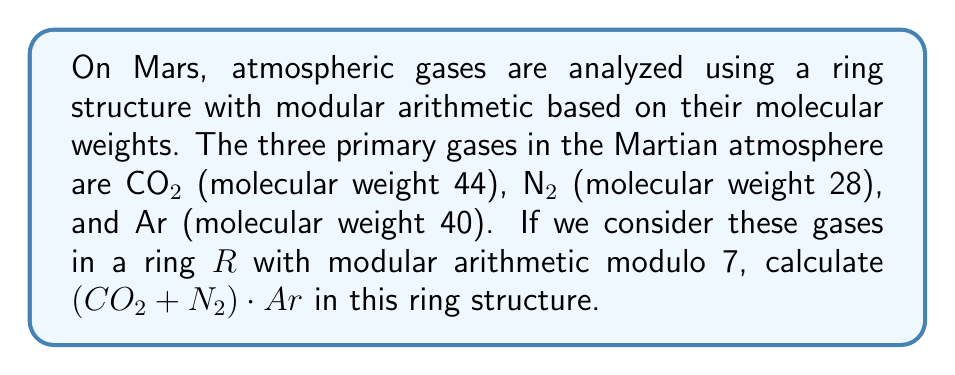Could you help me with this problem? To solve this problem, we need to follow these steps:

1) First, we need to convert the molecular weights to their equivalents in the ring $R$ with modulo 7 arithmetic:

   $CO₂: 44 \equiv 2 \pmod{7}$
   $N₂: 28 \equiv 0 \pmod{7}$
   $Ar: 40 \equiv 5 \pmod{7}$

2) Now, we can rewrite our expression $(CO₂ + N₂) \cdot Ar$ using these equivalents:

   $(2 + 0) \cdot 5$

3) Let's solve the addition inside the parentheses first:

   $2 + 0 = 2$

4) Now we have:

   $2 \cdot 5$

5) In modular arithmetic, we multiply as usual and then take the result modulo 7:

   $2 \cdot 5 = 10 \equiv 3 \pmod{7}$

Therefore, in the ring $R$ with modulo 7 arithmetic, $(CO₂ + N₂) \cdot Ar \equiv 3 \pmod{7}$.
Answer: $3$ 